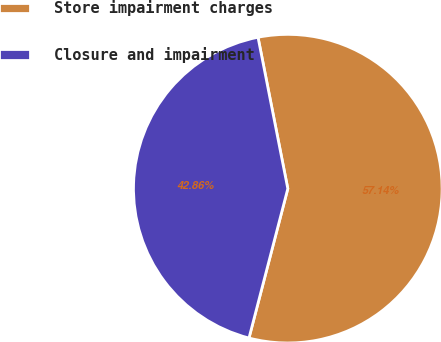Convert chart to OTSL. <chart><loc_0><loc_0><loc_500><loc_500><pie_chart><fcel>Store impairment charges<fcel>Closure and impairment<nl><fcel>57.14%<fcel>42.86%<nl></chart> 